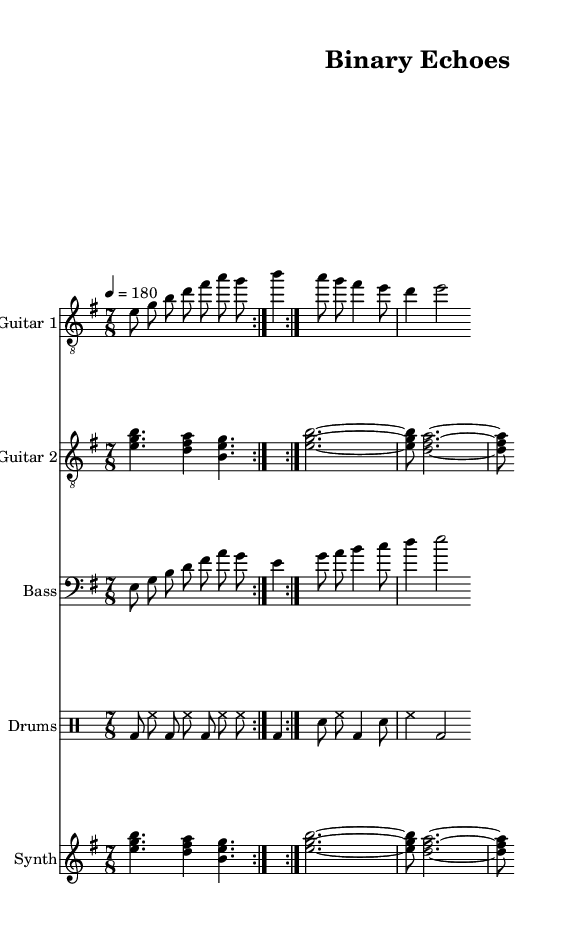What is the key signature of this music? The key signature is E minor, which has one sharp (F#). This can be determined by looking at the key signature indicated at the beginning of the music.
Answer: E minor What is the time signature of this piece? The time signature is 7/8, as displayed at the start of the music. This indicates that there are seven eighth notes per measure.
Answer: 7/8 What is the tempo marking for this piece? The tempo is marked as quarter note equals 180, which indicates the speed of the piece. This is found near the top of the music, right after the time signature.
Answer: 180 How many measures are repeated in the guitar parts? Both guitar parts show a repeat sign after the first section, indicating that these measures are played twice. This is a common feature in progressive metal, allowing for thematic repetition.
Answer: 2 Which instruments are involved in this piece? The piece includes Guitar 1, Guitar 2, Bass, Drums, and Synth. The title of each staff provides this information. This variety is typical in progressive metal to create a dense and layered sound.
Answer: Guitar 1, Guitar 2, Bass, Drums, Synth How does the rhythm in the drum section emphasize the piece's metal genre? The drum part features a consistent pattern of bass and hi-hat that creates a driving force typical of metal music. By analyzing the structured use of persistent eighth notes and steady bass drums, we can characterize it as aggressive and forceful.
Answer: Aggressive rhythm 